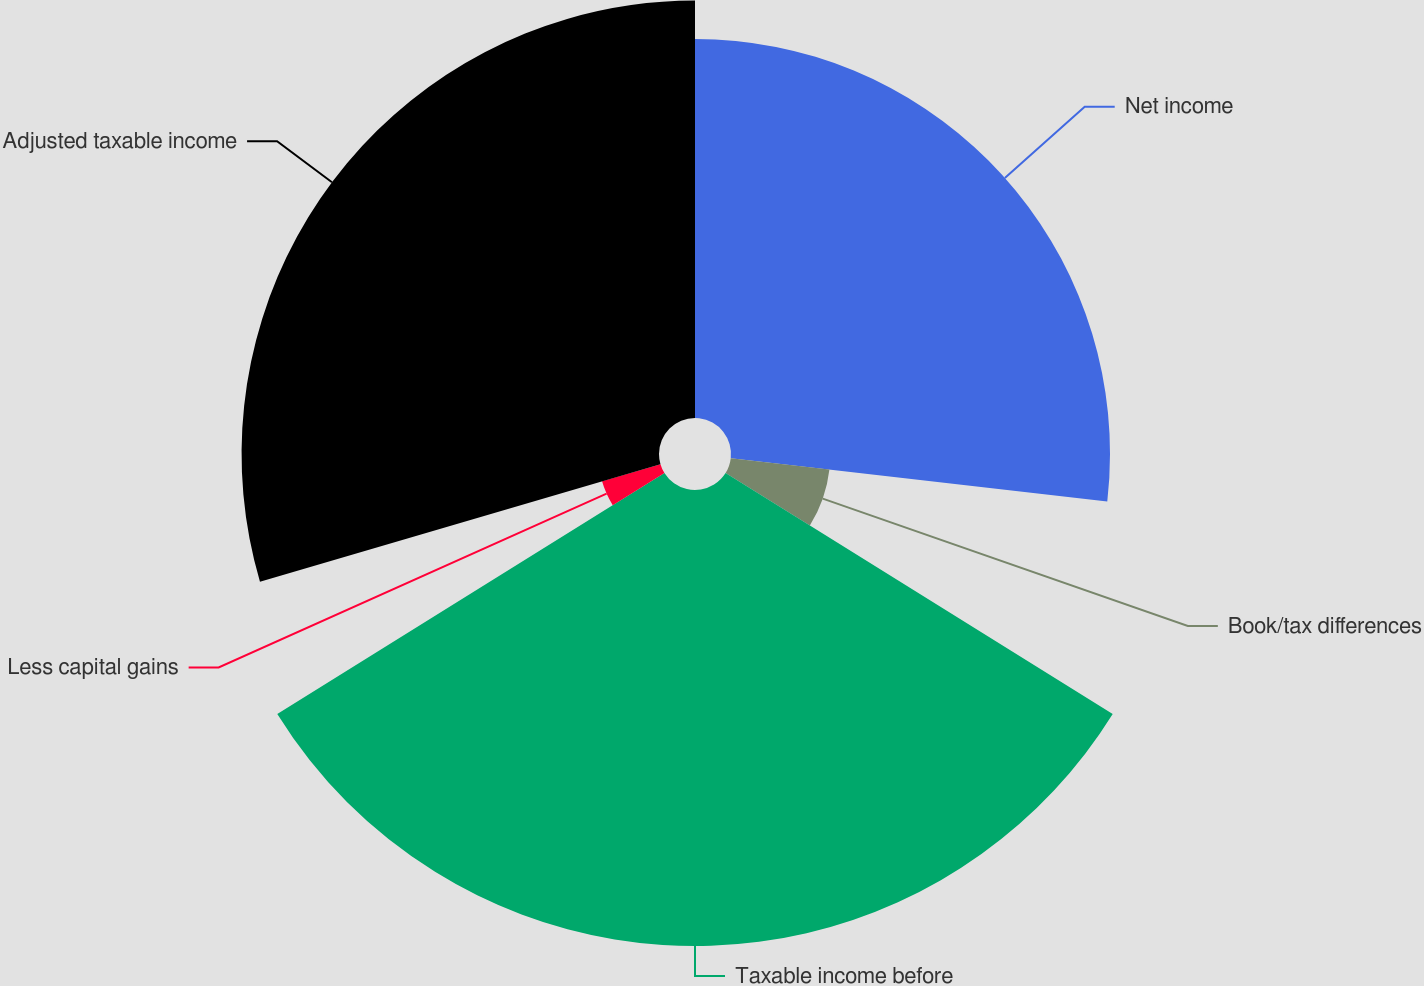Convert chart. <chart><loc_0><loc_0><loc_500><loc_500><pie_chart><fcel>Net income<fcel>Book/tax differences<fcel>Taxable income before<fcel>Less capital gains<fcel>Adjusted taxable income<nl><fcel>26.83%<fcel>7.03%<fcel>32.28%<fcel>4.31%<fcel>29.55%<nl></chart> 